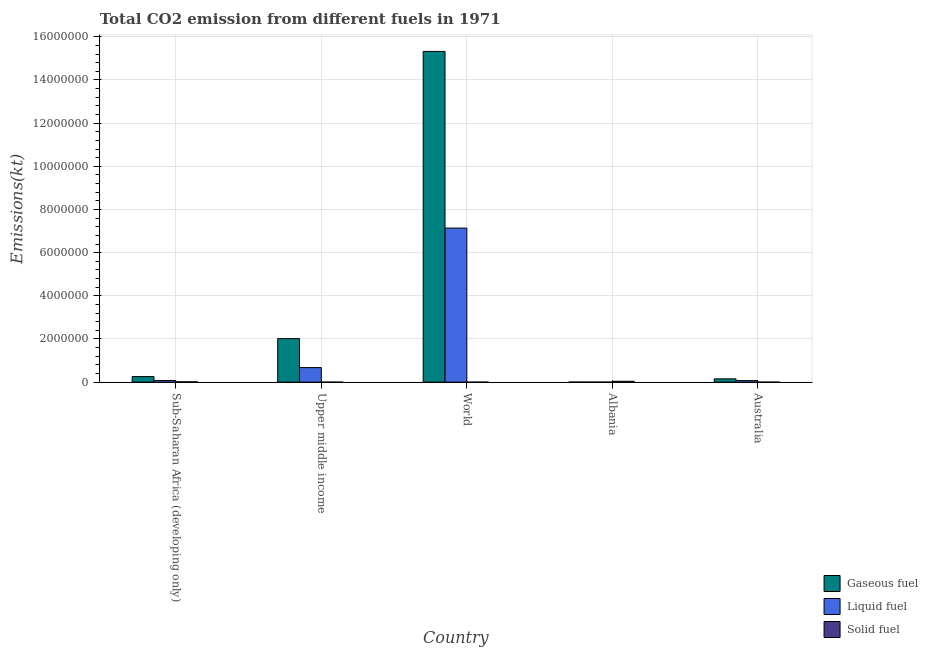How many different coloured bars are there?
Your answer should be compact. 3. Are the number of bars on each tick of the X-axis equal?
Your answer should be very brief. Yes. How many bars are there on the 3rd tick from the left?
Keep it short and to the point. 3. How many bars are there on the 1st tick from the right?
Give a very brief answer. 3. In how many cases, is the number of bars for a given country not equal to the number of legend labels?
Provide a short and direct response. 0. What is the amount of co2 emissions from liquid fuel in Upper middle income?
Ensure brevity in your answer.  6.75e+05. Across all countries, what is the maximum amount of co2 emissions from gaseous fuel?
Provide a short and direct response. 1.53e+07. Across all countries, what is the minimum amount of co2 emissions from liquid fuel?
Offer a terse response. 2940.93. In which country was the amount of co2 emissions from solid fuel minimum?
Offer a terse response. Upper middle income. What is the total amount of co2 emissions from solid fuel in the graph?
Give a very brief answer. 5.55e+04. What is the difference between the amount of co2 emissions from gaseous fuel in Australia and that in World?
Provide a short and direct response. -1.52e+07. What is the difference between the amount of co2 emissions from solid fuel in Australia and the amount of co2 emissions from gaseous fuel in Sub-Saharan Africa (developing only)?
Your answer should be compact. -2.57e+05. What is the average amount of co2 emissions from solid fuel per country?
Offer a very short reply. 1.11e+04. What is the difference between the amount of co2 emissions from solid fuel and amount of co2 emissions from liquid fuel in Australia?
Offer a terse response. -7.20e+04. In how many countries, is the amount of co2 emissions from solid fuel greater than 10000000 kt?
Keep it short and to the point. 0. What is the ratio of the amount of co2 emissions from gaseous fuel in Australia to that in Sub-Saharan Africa (developing only)?
Ensure brevity in your answer.  0.59. Is the difference between the amount of co2 emissions from gaseous fuel in Albania and World greater than the difference between the amount of co2 emissions from liquid fuel in Albania and World?
Your answer should be compact. No. What is the difference between the highest and the second highest amount of co2 emissions from solid fuel?
Make the answer very short. 2.54e+04. What is the difference between the highest and the lowest amount of co2 emissions from solid fuel?
Your answer should be compact. 4.04e+04. In how many countries, is the amount of co2 emissions from gaseous fuel greater than the average amount of co2 emissions from gaseous fuel taken over all countries?
Offer a terse response. 1. What does the 1st bar from the left in World represents?
Your answer should be very brief. Gaseous fuel. What does the 3rd bar from the right in Upper middle income represents?
Keep it short and to the point. Gaseous fuel. Is it the case that in every country, the sum of the amount of co2 emissions from gaseous fuel and amount of co2 emissions from liquid fuel is greater than the amount of co2 emissions from solid fuel?
Your answer should be compact. No. How many bars are there?
Offer a terse response. 15. Are all the bars in the graph horizontal?
Offer a terse response. No. How many countries are there in the graph?
Your answer should be very brief. 5. What is the difference between two consecutive major ticks on the Y-axis?
Your answer should be very brief. 2.00e+06. Does the graph contain any zero values?
Provide a short and direct response. No. Does the graph contain grids?
Provide a short and direct response. Yes. How many legend labels are there?
Give a very brief answer. 3. What is the title of the graph?
Offer a very short reply. Total CO2 emission from different fuels in 1971. What is the label or title of the Y-axis?
Provide a short and direct response. Emissions(kt). What is the Emissions(kt) in Gaseous fuel in Sub-Saharan Africa (developing only)?
Provide a short and direct response. 2.57e+05. What is the Emissions(kt) in Liquid fuel in Sub-Saharan Africa (developing only)?
Make the answer very short. 7.69e+04. What is the Emissions(kt) in Solid fuel in Sub-Saharan Africa (developing only)?
Make the answer very short. 1.51e+04. What is the Emissions(kt) in Gaseous fuel in Upper middle income?
Provide a succinct answer. 2.02e+06. What is the Emissions(kt) of Liquid fuel in Upper middle income?
Keep it short and to the point. 6.75e+05. What is the Emissions(kt) in Solid fuel in Upper middle income?
Give a very brief answer. 3.67. What is the Emissions(kt) in Gaseous fuel in World?
Ensure brevity in your answer.  1.53e+07. What is the Emissions(kt) in Liquid fuel in World?
Offer a terse response. 7.14e+06. What is the Emissions(kt) of Solid fuel in World?
Provide a succinct answer. 36.67. What is the Emissions(kt) in Gaseous fuel in Albania?
Offer a terse response. 4352.73. What is the Emissions(kt) of Liquid fuel in Albania?
Your answer should be compact. 2940.93. What is the Emissions(kt) of Solid fuel in Albania?
Your response must be concise. 4.04e+04. What is the Emissions(kt) in Gaseous fuel in Australia?
Provide a short and direct response. 1.53e+05. What is the Emissions(kt) in Liquid fuel in Australia?
Provide a succinct answer. 7.20e+04. What is the Emissions(kt) in Solid fuel in Australia?
Your answer should be compact. 3.67. Across all countries, what is the maximum Emissions(kt) in Gaseous fuel?
Give a very brief answer. 1.53e+07. Across all countries, what is the maximum Emissions(kt) of Liquid fuel?
Keep it short and to the point. 7.14e+06. Across all countries, what is the maximum Emissions(kt) in Solid fuel?
Give a very brief answer. 4.04e+04. Across all countries, what is the minimum Emissions(kt) in Gaseous fuel?
Give a very brief answer. 4352.73. Across all countries, what is the minimum Emissions(kt) in Liquid fuel?
Your response must be concise. 2940.93. Across all countries, what is the minimum Emissions(kt) in Solid fuel?
Make the answer very short. 3.67. What is the total Emissions(kt) of Gaseous fuel in the graph?
Make the answer very short. 1.78e+07. What is the total Emissions(kt) of Liquid fuel in the graph?
Your answer should be compact. 7.96e+06. What is the total Emissions(kt) in Solid fuel in the graph?
Offer a terse response. 5.55e+04. What is the difference between the Emissions(kt) of Gaseous fuel in Sub-Saharan Africa (developing only) and that in Upper middle income?
Provide a succinct answer. -1.76e+06. What is the difference between the Emissions(kt) in Liquid fuel in Sub-Saharan Africa (developing only) and that in Upper middle income?
Provide a succinct answer. -5.98e+05. What is the difference between the Emissions(kt) of Solid fuel in Sub-Saharan Africa (developing only) and that in Upper middle income?
Offer a very short reply. 1.51e+04. What is the difference between the Emissions(kt) in Gaseous fuel in Sub-Saharan Africa (developing only) and that in World?
Your response must be concise. -1.51e+07. What is the difference between the Emissions(kt) in Liquid fuel in Sub-Saharan Africa (developing only) and that in World?
Give a very brief answer. -7.06e+06. What is the difference between the Emissions(kt) of Solid fuel in Sub-Saharan Africa (developing only) and that in World?
Offer a very short reply. 1.50e+04. What is the difference between the Emissions(kt) of Gaseous fuel in Sub-Saharan Africa (developing only) and that in Albania?
Offer a very short reply. 2.53e+05. What is the difference between the Emissions(kt) in Liquid fuel in Sub-Saharan Africa (developing only) and that in Albania?
Ensure brevity in your answer.  7.40e+04. What is the difference between the Emissions(kt) in Solid fuel in Sub-Saharan Africa (developing only) and that in Albania?
Your response must be concise. -2.54e+04. What is the difference between the Emissions(kt) of Gaseous fuel in Sub-Saharan Africa (developing only) and that in Australia?
Offer a very short reply. 1.05e+05. What is the difference between the Emissions(kt) of Liquid fuel in Sub-Saharan Africa (developing only) and that in Australia?
Provide a short and direct response. 4890.95. What is the difference between the Emissions(kt) of Solid fuel in Sub-Saharan Africa (developing only) and that in Australia?
Provide a short and direct response. 1.51e+04. What is the difference between the Emissions(kt) in Gaseous fuel in Upper middle income and that in World?
Your answer should be compact. -1.33e+07. What is the difference between the Emissions(kt) of Liquid fuel in Upper middle income and that in World?
Give a very brief answer. -6.46e+06. What is the difference between the Emissions(kt) in Solid fuel in Upper middle income and that in World?
Your response must be concise. -33. What is the difference between the Emissions(kt) of Gaseous fuel in Upper middle income and that in Albania?
Offer a terse response. 2.01e+06. What is the difference between the Emissions(kt) of Liquid fuel in Upper middle income and that in Albania?
Offer a terse response. 6.72e+05. What is the difference between the Emissions(kt) in Solid fuel in Upper middle income and that in Albania?
Make the answer very short. -4.04e+04. What is the difference between the Emissions(kt) in Gaseous fuel in Upper middle income and that in Australia?
Make the answer very short. 1.87e+06. What is the difference between the Emissions(kt) of Liquid fuel in Upper middle income and that in Australia?
Give a very brief answer. 6.03e+05. What is the difference between the Emissions(kt) in Solid fuel in Upper middle income and that in Australia?
Offer a terse response. 0. What is the difference between the Emissions(kt) of Gaseous fuel in World and that in Albania?
Offer a terse response. 1.53e+07. What is the difference between the Emissions(kt) of Liquid fuel in World and that in Albania?
Ensure brevity in your answer.  7.13e+06. What is the difference between the Emissions(kt) in Solid fuel in World and that in Albania?
Give a very brief answer. -4.04e+04. What is the difference between the Emissions(kt) in Gaseous fuel in World and that in Australia?
Offer a terse response. 1.52e+07. What is the difference between the Emissions(kt) in Liquid fuel in World and that in Australia?
Provide a short and direct response. 7.07e+06. What is the difference between the Emissions(kt) in Solid fuel in World and that in Australia?
Offer a terse response. 33. What is the difference between the Emissions(kt) in Gaseous fuel in Albania and that in Australia?
Offer a very short reply. -1.48e+05. What is the difference between the Emissions(kt) of Liquid fuel in Albania and that in Australia?
Offer a terse response. -6.91e+04. What is the difference between the Emissions(kt) of Solid fuel in Albania and that in Australia?
Ensure brevity in your answer.  4.04e+04. What is the difference between the Emissions(kt) in Gaseous fuel in Sub-Saharan Africa (developing only) and the Emissions(kt) in Liquid fuel in Upper middle income?
Offer a terse response. -4.17e+05. What is the difference between the Emissions(kt) of Gaseous fuel in Sub-Saharan Africa (developing only) and the Emissions(kt) of Solid fuel in Upper middle income?
Your answer should be very brief. 2.57e+05. What is the difference between the Emissions(kt) in Liquid fuel in Sub-Saharan Africa (developing only) and the Emissions(kt) in Solid fuel in Upper middle income?
Offer a very short reply. 7.69e+04. What is the difference between the Emissions(kt) in Gaseous fuel in Sub-Saharan Africa (developing only) and the Emissions(kt) in Liquid fuel in World?
Your answer should be very brief. -6.88e+06. What is the difference between the Emissions(kt) in Gaseous fuel in Sub-Saharan Africa (developing only) and the Emissions(kt) in Solid fuel in World?
Provide a short and direct response. 2.57e+05. What is the difference between the Emissions(kt) in Liquid fuel in Sub-Saharan Africa (developing only) and the Emissions(kt) in Solid fuel in World?
Make the answer very short. 7.69e+04. What is the difference between the Emissions(kt) in Gaseous fuel in Sub-Saharan Africa (developing only) and the Emissions(kt) in Liquid fuel in Albania?
Offer a terse response. 2.54e+05. What is the difference between the Emissions(kt) of Gaseous fuel in Sub-Saharan Africa (developing only) and the Emissions(kt) of Solid fuel in Albania?
Your response must be concise. 2.17e+05. What is the difference between the Emissions(kt) of Liquid fuel in Sub-Saharan Africa (developing only) and the Emissions(kt) of Solid fuel in Albania?
Your response must be concise. 3.65e+04. What is the difference between the Emissions(kt) in Gaseous fuel in Sub-Saharan Africa (developing only) and the Emissions(kt) in Liquid fuel in Australia?
Provide a succinct answer. 1.85e+05. What is the difference between the Emissions(kt) of Gaseous fuel in Sub-Saharan Africa (developing only) and the Emissions(kt) of Solid fuel in Australia?
Your answer should be very brief. 2.57e+05. What is the difference between the Emissions(kt) of Liquid fuel in Sub-Saharan Africa (developing only) and the Emissions(kt) of Solid fuel in Australia?
Give a very brief answer. 7.69e+04. What is the difference between the Emissions(kt) in Gaseous fuel in Upper middle income and the Emissions(kt) in Liquid fuel in World?
Provide a succinct answer. -5.12e+06. What is the difference between the Emissions(kt) in Gaseous fuel in Upper middle income and the Emissions(kt) in Solid fuel in World?
Keep it short and to the point. 2.02e+06. What is the difference between the Emissions(kt) of Liquid fuel in Upper middle income and the Emissions(kt) of Solid fuel in World?
Offer a terse response. 6.75e+05. What is the difference between the Emissions(kt) in Gaseous fuel in Upper middle income and the Emissions(kt) in Liquid fuel in Albania?
Offer a terse response. 2.02e+06. What is the difference between the Emissions(kt) of Gaseous fuel in Upper middle income and the Emissions(kt) of Solid fuel in Albania?
Give a very brief answer. 1.98e+06. What is the difference between the Emissions(kt) of Liquid fuel in Upper middle income and the Emissions(kt) of Solid fuel in Albania?
Keep it short and to the point. 6.34e+05. What is the difference between the Emissions(kt) of Gaseous fuel in Upper middle income and the Emissions(kt) of Liquid fuel in Australia?
Provide a short and direct response. 1.95e+06. What is the difference between the Emissions(kt) in Gaseous fuel in Upper middle income and the Emissions(kt) in Solid fuel in Australia?
Provide a succinct answer. 2.02e+06. What is the difference between the Emissions(kt) in Liquid fuel in Upper middle income and the Emissions(kt) in Solid fuel in Australia?
Keep it short and to the point. 6.75e+05. What is the difference between the Emissions(kt) in Gaseous fuel in World and the Emissions(kt) in Liquid fuel in Albania?
Offer a terse response. 1.53e+07. What is the difference between the Emissions(kt) of Gaseous fuel in World and the Emissions(kt) of Solid fuel in Albania?
Offer a terse response. 1.53e+07. What is the difference between the Emissions(kt) of Liquid fuel in World and the Emissions(kt) of Solid fuel in Albania?
Offer a terse response. 7.10e+06. What is the difference between the Emissions(kt) in Gaseous fuel in World and the Emissions(kt) in Liquid fuel in Australia?
Give a very brief answer. 1.53e+07. What is the difference between the Emissions(kt) of Gaseous fuel in World and the Emissions(kt) of Solid fuel in Australia?
Make the answer very short. 1.53e+07. What is the difference between the Emissions(kt) of Liquid fuel in World and the Emissions(kt) of Solid fuel in Australia?
Ensure brevity in your answer.  7.14e+06. What is the difference between the Emissions(kt) of Gaseous fuel in Albania and the Emissions(kt) of Liquid fuel in Australia?
Your answer should be compact. -6.77e+04. What is the difference between the Emissions(kt) of Gaseous fuel in Albania and the Emissions(kt) of Solid fuel in Australia?
Make the answer very short. 4349.06. What is the difference between the Emissions(kt) in Liquid fuel in Albania and the Emissions(kt) in Solid fuel in Australia?
Your answer should be compact. 2937.27. What is the average Emissions(kt) of Gaseous fuel per country?
Keep it short and to the point. 3.55e+06. What is the average Emissions(kt) of Liquid fuel per country?
Offer a very short reply. 1.59e+06. What is the average Emissions(kt) of Solid fuel per country?
Keep it short and to the point. 1.11e+04. What is the difference between the Emissions(kt) in Gaseous fuel and Emissions(kt) in Liquid fuel in Sub-Saharan Africa (developing only)?
Provide a short and direct response. 1.81e+05. What is the difference between the Emissions(kt) of Gaseous fuel and Emissions(kt) of Solid fuel in Sub-Saharan Africa (developing only)?
Your answer should be very brief. 2.42e+05. What is the difference between the Emissions(kt) in Liquid fuel and Emissions(kt) in Solid fuel in Sub-Saharan Africa (developing only)?
Offer a terse response. 6.18e+04. What is the difference between the Emissions(kt) of Gaseous fuel and Emissions(kt) of Liquid fuel in Upper middle income?
Offer a terse response. 1.34e+06. What is the difference between the Emissions(kt) in Gaseous fuel and Emissions(kt) in Solid fuel in Upper middle income?
Ensure brevity in your answer.  2.02e+06. What is the difference between the Emissions(kt) in Liquid fuel and Emissions(kt) in Solid fuel in Upper middle income?
Your response must be concise. 6.75e+05. What is the difference between the Emissions(kt) of Gaseous fuel and Emissions(kt) of Liquid fuel in World?
Provide a short and direct response. 8.19e+06. What is the difference between the Emissions(kt) in Gaseous fuel and Emissions(kt) in Solid fuel in World?
Ensure brevity in your answer.  1.53e+07. What is the difference between the Emissions(kt) in Liquid fuel and Emissions(kt) in Solid fuel in World?
Your answer should be compact. 7.14e+06. What is the difference between the Emissions(kt) in Gaseous fuel and Emissions(kt) in Liquid fuel in Albania?
Your answer should be very brief. 1411.8. What is the difference between the Emissions(kt) of Gaseous fuel and Emissions(kt) of Solid fuel in Albania?
Your answer should be compact. -3.61e+04. What is the difference between the Emissions(kt) of Liquid fuel and Emissions(kt) of Solid fuel in Albania?
Keep it short and to the point. -3.75e+04. What is the difference between the Emissions(kt) of Gaseous fuel and Emissions(kt) of Liquid fuel in Australia?
Give a very brief answer. 8.08e+04. What is the difference between the Emissions(kt) in Gaseous fuel and Emissions(kt) in Solid fuel in Australia?
Make the answer very short. 1.53e+05. What is the difference between the Emissions(kt) in Liquid fuel and Emissions(kt) in Solid fuel in Australia?
Keep it short and to the point. 7.20e+04. What is the ratio of the Emissions(kt) of Gaseous fuel in Sub-Saharan Africa (developing only) to that in Upper middle income?
Offer a terse response. 0.13. What is the ratio of the Emissions(kt) in Liquid fuel in Sub-Saharan Africa (developing only) to that in Upper middle income?
Your answer should be very brief. 0.11. What is the ratio of the Emissions(kt) of Solid fuel in Sub-Saharan Africa (developing only) to that in Upper middle income?
Give a very brief answer. 4107. What is the ratio of the Emissions(kt) in Gaseous fuel in Sub-Saharan Africa (developing only) to that in World?
Keep it short and to the point. 0.02. What is the ratio of the Emissions(kt) in Liquid fuel in Sub-Saharan Africa (developing only) to that in World?
Keep it short and to the point. 0.01. What is the ratio of the Emissions(kt) of Solid fuel in Sub-Saharan Africa (developing only) to that in World?
Offer a very short reply. 410.7. What is the ratio of the Emissions(kt) of Gaseous fuel in Sub-Saharan Africa (developing only) to that in Albania?
Provide a short and direct response. 59.14. What is the ratio of the Emissions(kt) of Liquid fuel in Sub-Saharan Africa (developing only) to that in Albania?
Keep it short and to the point. 26.15. What is the ratio of the Emissions(kt) in Solid fuel in Sub-Saharan Africa (developing only) to that in Albania?
Your answer should be very brief. 0.37. What is the ratio of the Emissions(kt) of Gaseous fuel in Sub-Saharan Africa (developing only) to that in Australia?
Provide a succinct answer. 1.69. What is the ratio of the Emissions(kt) of Liquid fuel in Sub-Saharan Africa (developing only) to that in Australia?
Your answer should be compact. 1.07. What is the ratio of the Emissions(kt) in Solid fuel in Sub-Saharan Africa (developing only) to that in Australia?
Keep it short and to the point. 4107. What is the ratio of the Emissions(kt) of Gaseous fuel in Upper middle income to that in World?
Provide a succinct answer. 0.13. What is the ratio of the Emissions(kt) in Liquid fuel in Upper middle income to that in World?
Make the answer very short. 0.09. What is the ratio of the Emissions(kt) in Gaseous fuel in Upper middle income to that in Albania?
Give a very brief answer. 463.69. What is the ratio of the Emissions(kt) in Liquid fuel in Upper middle income to that in Albania?
Your answer should be very brief. 229.38. What is the ratio of the Emissions(kt) in Solid fuel in Upper middle income to that in Albania?
Your answer should be compact. 0. What is the ratio of the Emissions(kt) in Gaseous fuel in Upper middle income to that in Australia?
Your answer should be compact. 13.21. What is the ratio of the Emissions(kt) in Liquid fuel in Upper middle income to that in Australia?
Your answer should be compact. 9.37. What is the ratio of the Emissions(kt) of Gaseous fuel in World to that in Albania?
Your answer should be compact. 3520.36. What is the ratio of the Emissions(kt) of Liquid fuel in World to that in Albania?
Ensure brevity in your answer.  2426.97. What is the ratio of the Emissions(kt) in Solid fuel in World to that in Albania?
Make the answer very short. 0. What is the ratio of the Emissions(kt) of Gaseous fuel in World to that in Australia?
Make the answer very short. 100.3. What is the ratio of the Emissions(kt) in Liquid fuel in World to that in Australia?
Your response must be concise. 99.12. What is the ratio of the Emissions(kt) of Solid fuel in World to that in Australia?
Your response must be concise. 10. What is the ratio of the Emissions(kt) in Gaseous fuel in Albania to that in Australia?
Keep it short and to the point. 0.03. What is the ratio of the Emissions(kt) in Liquid fuel in Albania to that in Australia?
Give a very brief answer. 0.04. What is the ratio of the Emissions(kt) of Solid fuel in Albania to that in Australia?
Keep it short and to the point. 1.10e+04. What is the difference between the highest and the second highest Emissions(kt) of Gaseous fuel?
Make the answer very short. 1.33e+07. What is the difference between the highest and the second highest Emissions(kt) of Liquid fuel?
Your answer should be very brief. 6.46e+06. What is the difference between the highest and the second highest Emissions(kt) of Solid fuel?
Offer a very short reply. 2.54e+04. What is the difference between the highest and the lowest Emissions(kt) of Gaseous fuel?
Offer a terse response. 1.53e+07. What is the difference between the highest and the lowest Emissions(kt) in Liquid fuel?
Make the answer very short. 7.13e+06. What is the difference between the highest and the lowest Emissions(kt) of Solid fuel?
Your answer should be very brief. 4.04e+04. 